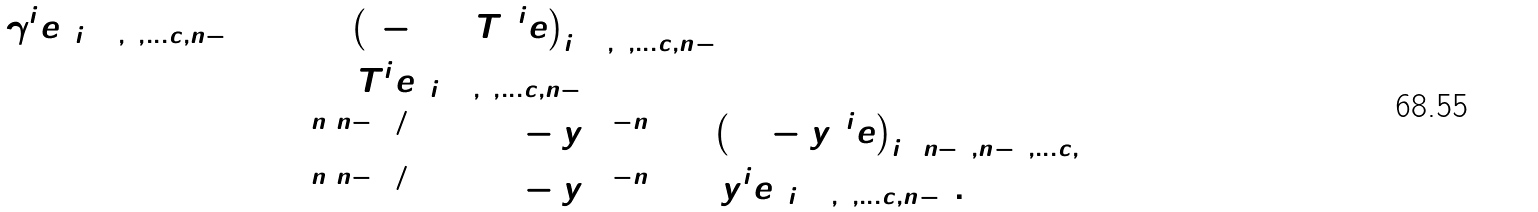Convert formula to latex. <formula><loc_0><loc_0><loc_500><loc_500>\det ( \gamma ^ { i } e ) _ { i = 0 , 1 , \dots c , n - 1 } & = \det \left ( ( - 1 + T ) ^ { i } e \right ) _ { i = 0 , 1 , \dots c , n - 1 } \\ & = \det ( T ^ { i } e ) _ { i = 0 , 1 , \dots c , n - 1 } \\ & = 2 ^ { n ( n - 1 ) / 2 } \det ( 1 - y ) ^ { 1 - n } \det \left ( ( 1 - y ) ^ { i } e \right ) _ { i = n - 1 , n - 2 , \dots c , 0 } \\ & = 2 ^ { n ( n - 1 ) / 2 } \det ( 1 - y ) ^ { 1 - n } \det ( y ^ { i } e ) _ { i = 0 , 1 , \dots c , n - 1 } .</formula> 